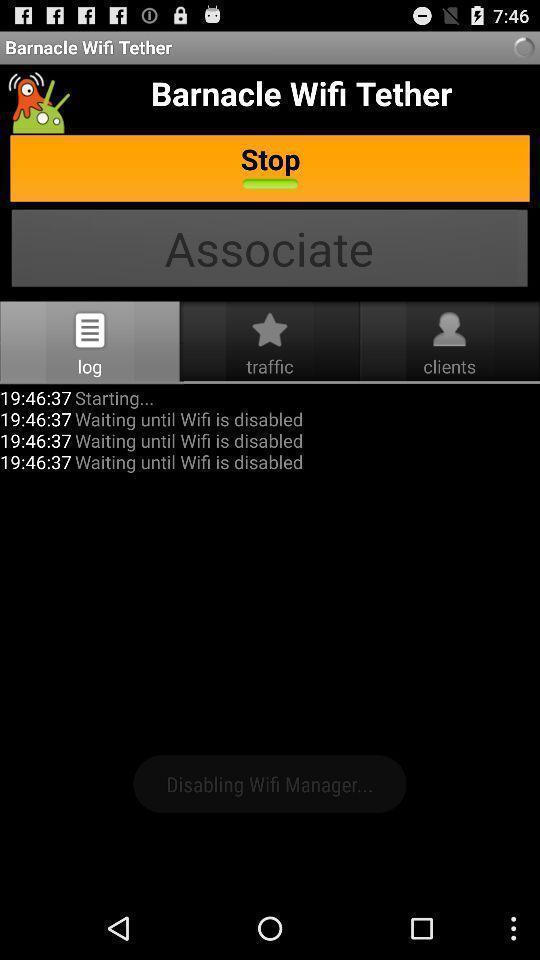Provide a description of this screenshot. Stop of the barnacle wifi tether of app. 